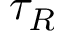Convert formula to latex. <formula><loc_0><loc_0><loc_500><loc_500>\tau _ { R }</formula> 